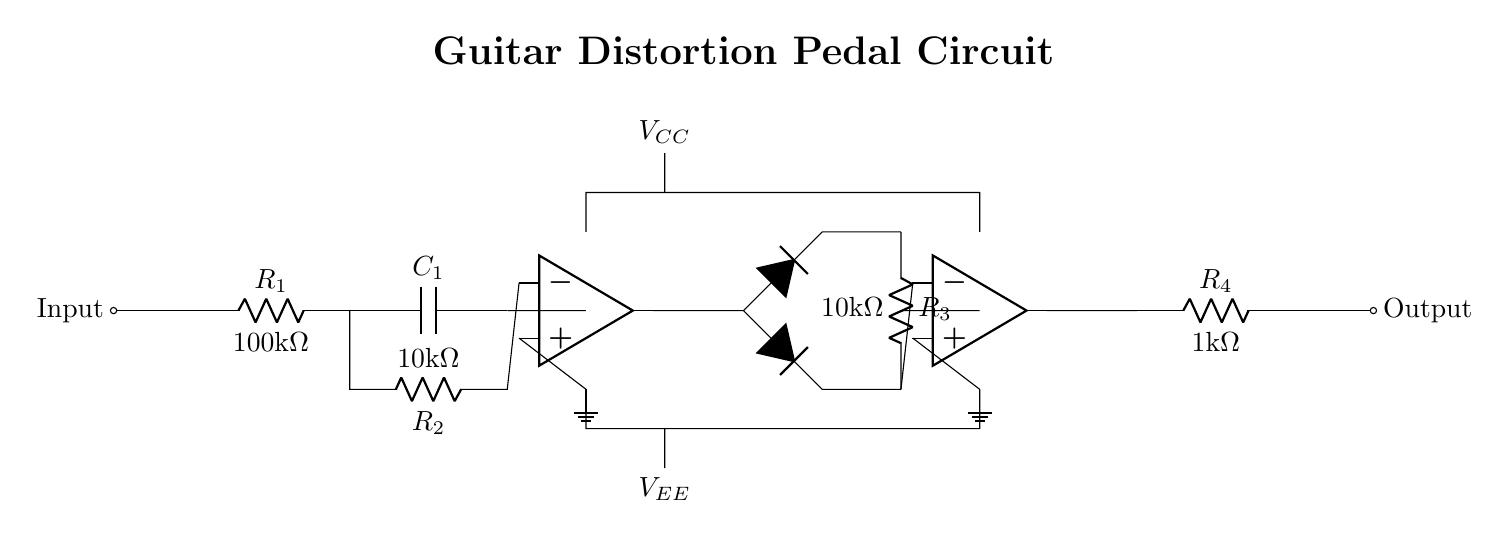What is the role of R1? R1 is a resistor in series with the input signal, primarily used to limit the current entering the circuit and to set the gain of the first op-amp stage.
Answer: Input current limiter What are the values of R2 and R3? R2 is 10k ohms and R3 is 10k ohms, as labeled in the circuit diagram. They provide feedback and clipping characteristics.
Answer: R2: 10k ohms, R3: 10k ohms How many op-amps are present in this circuit? There are two operational amplifiers in the circuit, which are responsible for amplifying the input signal and providing distortion characteristics.
Answer: Two What happens in the diode clipping stage? In this stage, two diodes perform clipping of the amplified signal by allowing current to flow in one direction only, cutting off the peaks of the waveform, which results in a distorted output.
Answer: Signal clipping What is the function of C1? C1 is a capacitor used to block any DC voltage present at the input, allowing only the AC signal (audio) to pass through into the first op-amp stage, which is essential for distortion circuits.
Answer: DC blocking What is the output stage load resistance value? The load resistance in the output stage is R4, which has a value of 1k ohm, as depicted in the circuit diagram. It influences the overall output impedance of the circuit.
Answer: 1k ohm What is the purpose of the \( V_{CC} \) and \( V_{EE} \) terminals? \( V_{CC} \) and \( V_{EE} \) are the power supply connections for the operational amplifiers. They provide the necessary positive and negative voltages, enabling the op-amps to function correctly.
Answer: Power supply terminals 